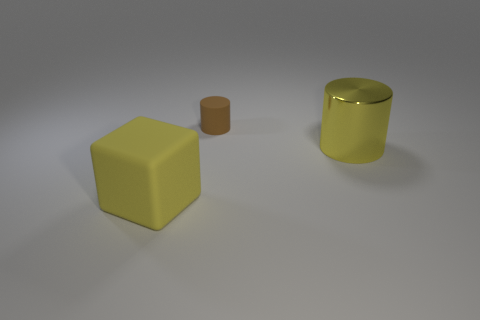Add 2 red things. How many objects exist? 5 Subtract all cubes. How many objects are left? 2 Add 2 large blue matte balls. How many large blue matte balls exist? 2 Subtract 1 yellow blocks. How many objects are left? 2 Subtract all small brown rubber cubes. Subtract all large yellow rubber objects. How many objects are left? 2 Add 1 cubes. How many cubes are left? 2 